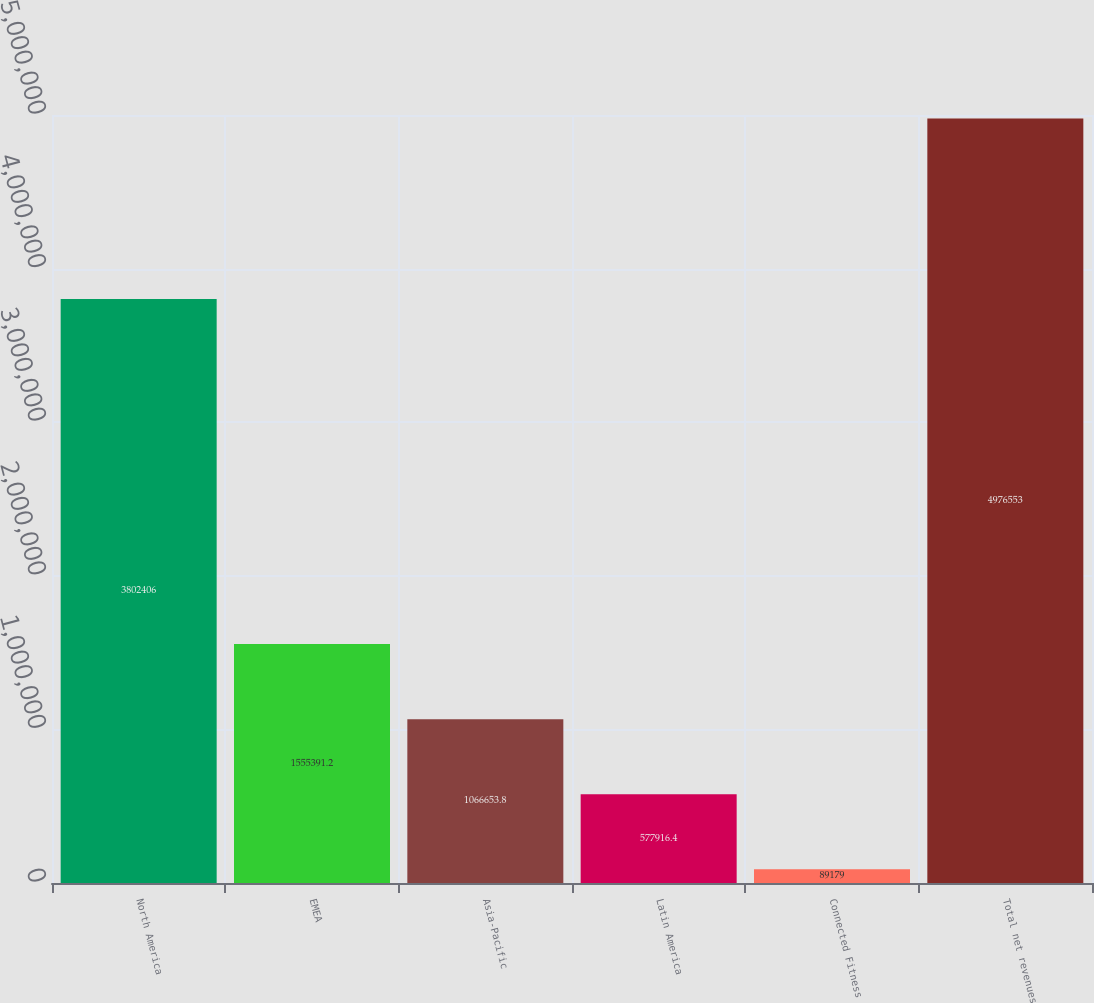<chart> <loc_0><loc_0><loc_500><loc_500><bar_chart><fcel>North America<fcel>EMEA<fcel>Asia-Pacific<fcel>Latin America<fcel>Connected Fitness<fcel>Total net revenues<nl><fcel>3.80241e+06<fcel>1.55539e+06<fcel>1.06665e+06<fcel>577916<fcel>89179<fcel>4.97655e+06<nl></chart> 